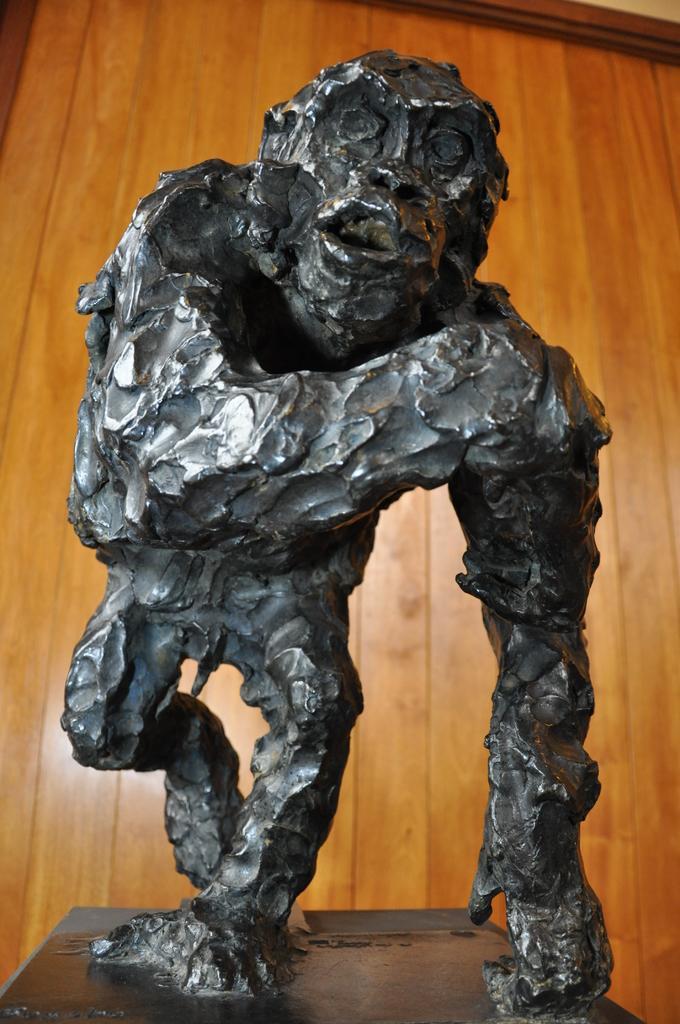Could you give a brief overview of what you see in this image? In this image we can see statue of a monkey which is in black color and in the background of the image there is wooden door. 